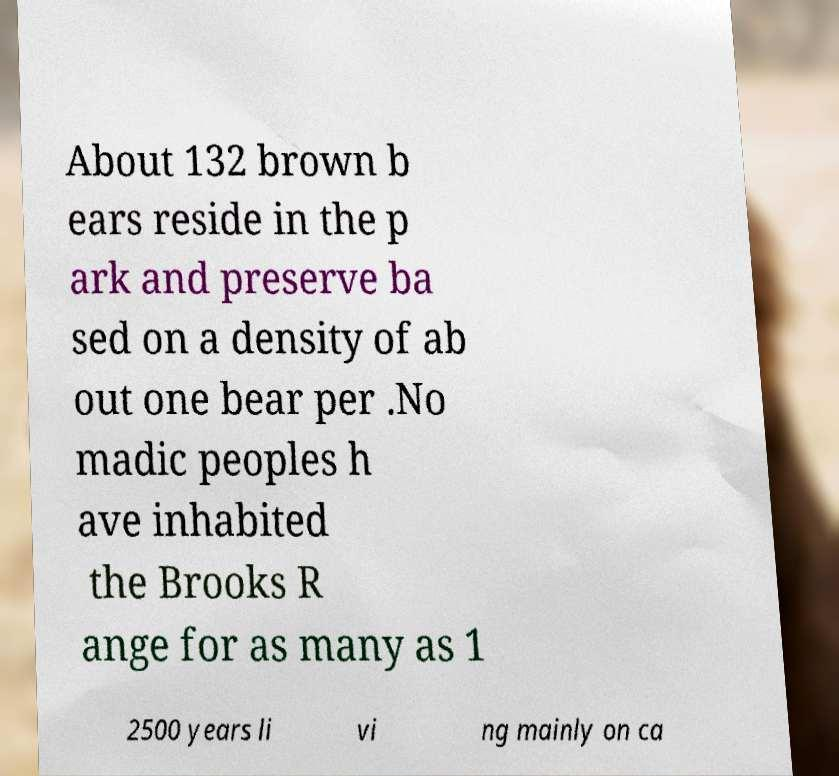There's text embedded in this image that I need extracted. Can you transcribe it verbatim? About 132 brown b ears reside in the p ark and preserve ba sed on a density of ab out one bear per .No madic peoples h ave inhabited the Brooks R ange for as many as 1 2500 years li vi ng mainly on ca 